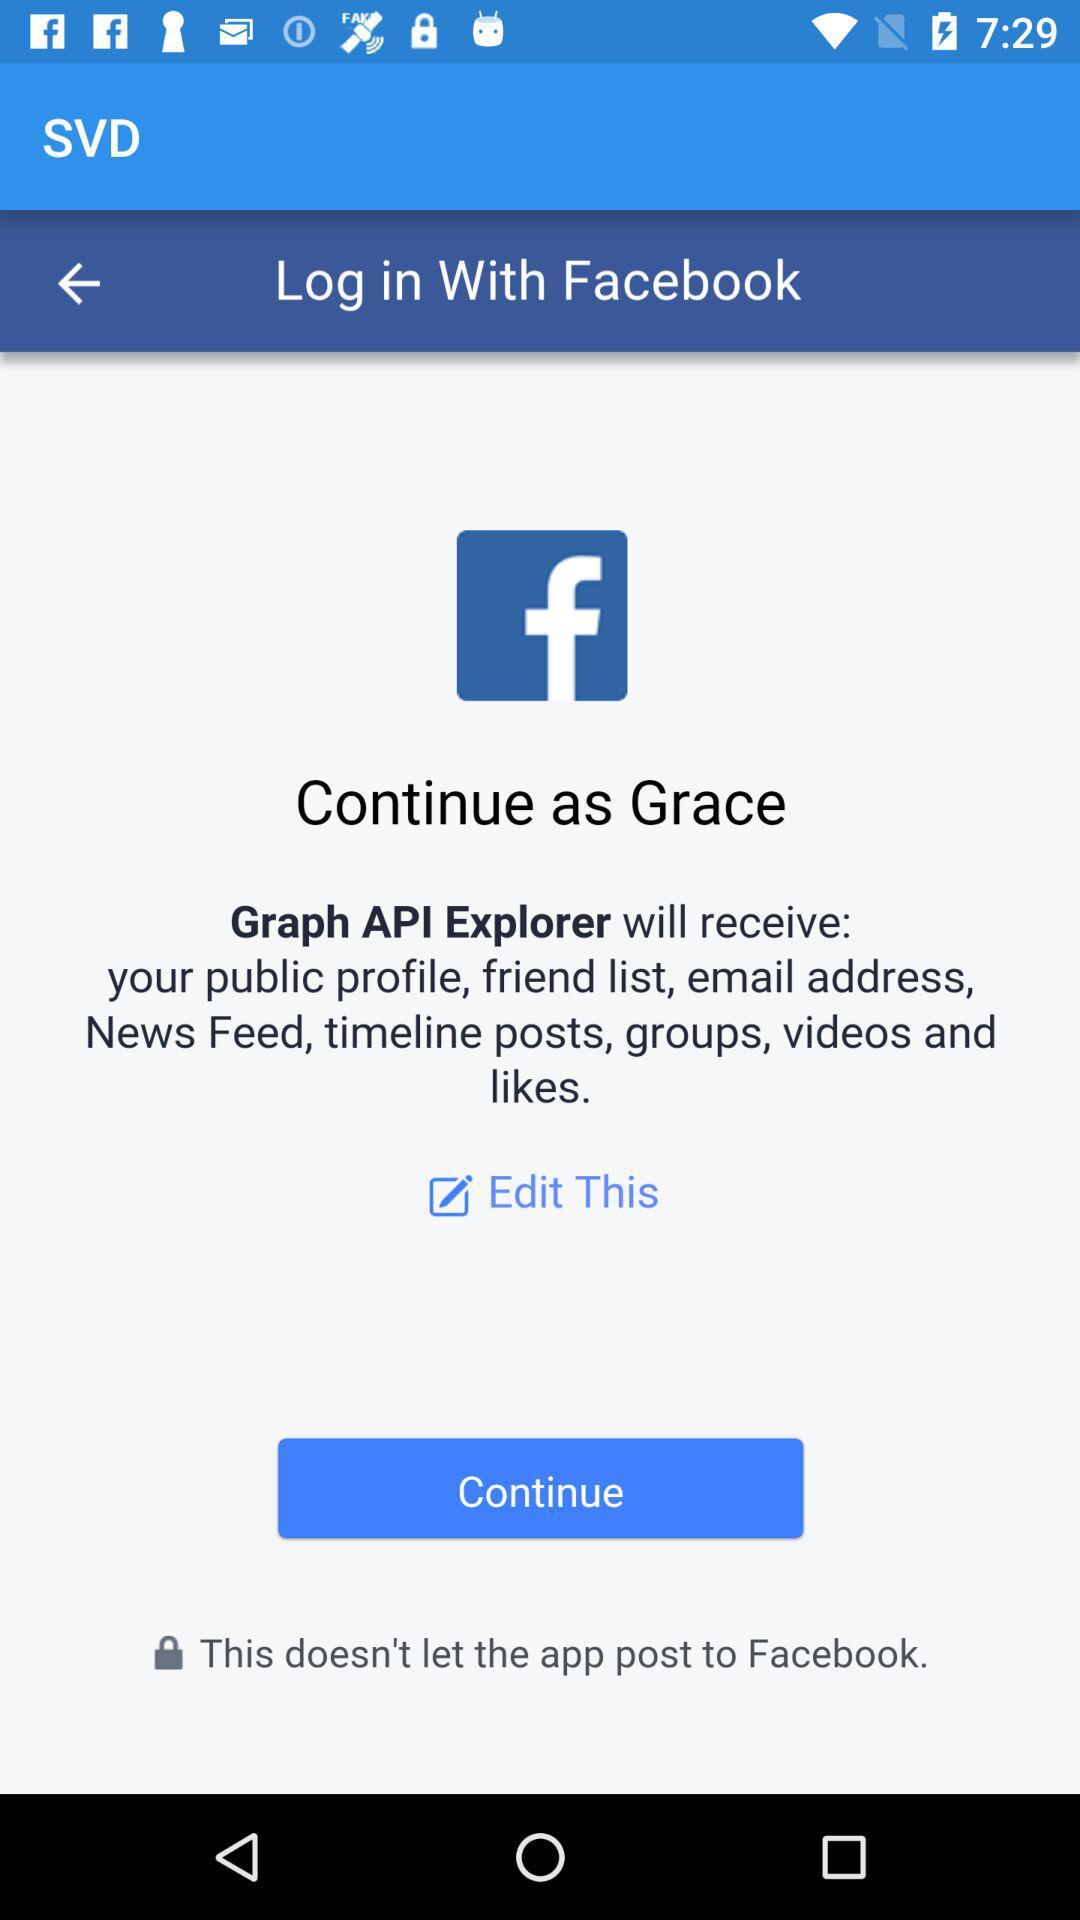What is the application name? The application name is "SVD". 